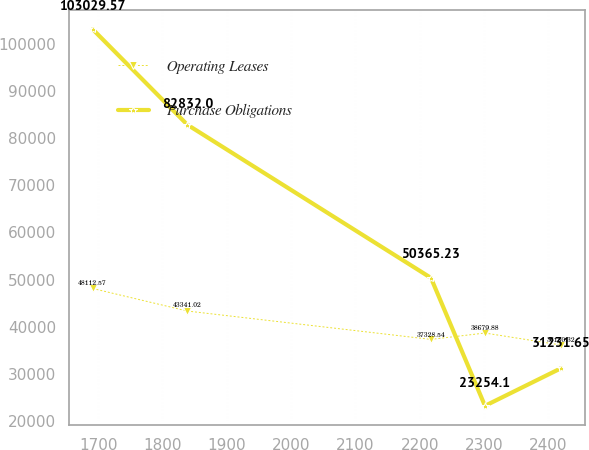Convert chart. <chart><loc_0><loc_0><loc_500><loc_500><line_chart><ecel><fcel>Operating Leases<fcel>Purchase Obligations<nl><fcel>1691.58<fcel>48112.6<fcel>103030<nl><fcel>1838.51<fcel>43341<fcel>82832<nl><fcel>2217.41<fcel>37328.5<fcel>50365.2<nl><fcel>2301.41<fcel>38679.9<fcel>23254.1<nl><fcel>2419.88<fcel>36130.3<fcel>31231.7<nl></chart> 